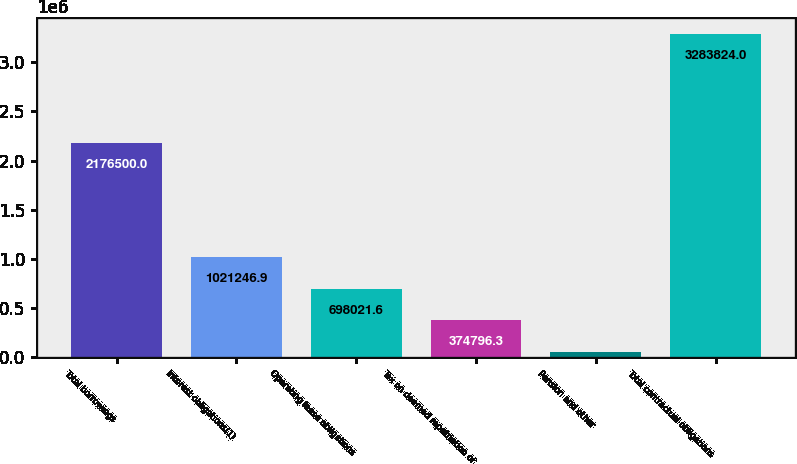<chart> <loc_0><loc_0><loc_500><loc_500><bar_chart><fcel>Total borrowings<fcel>Interest obligations(1)<fcel>Operating lease obligations<fcel>Tax on deemed repatriation of<fcel>Pension and other<fcel>Total contractual obligations<nl><fcel>2.1765e+06<fcel>1.02125e+06<fcel>698022<fcel>374796<fcel>51571<fcel>3.28382e+06<nl></chart> 